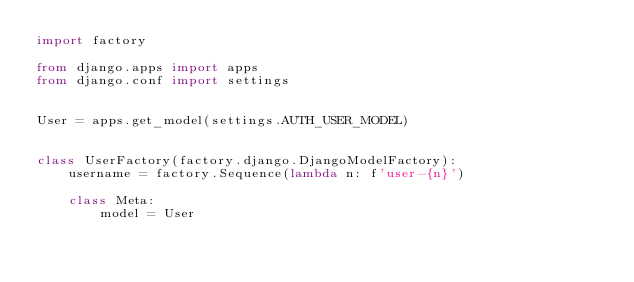<code> <loc_0><loc_0><loc_500><loc_500><_Python_>import factory

from django.apps import apps
from django.conf import settings


User = apps.get_model(settings.AUTH_USER_MODEL)


class UserFactory(factory.django.DjangoModelFactory):
    username = factory.Sequence(lambda n: f'user-{n}')

    class Meta:
        model = User
</code> 